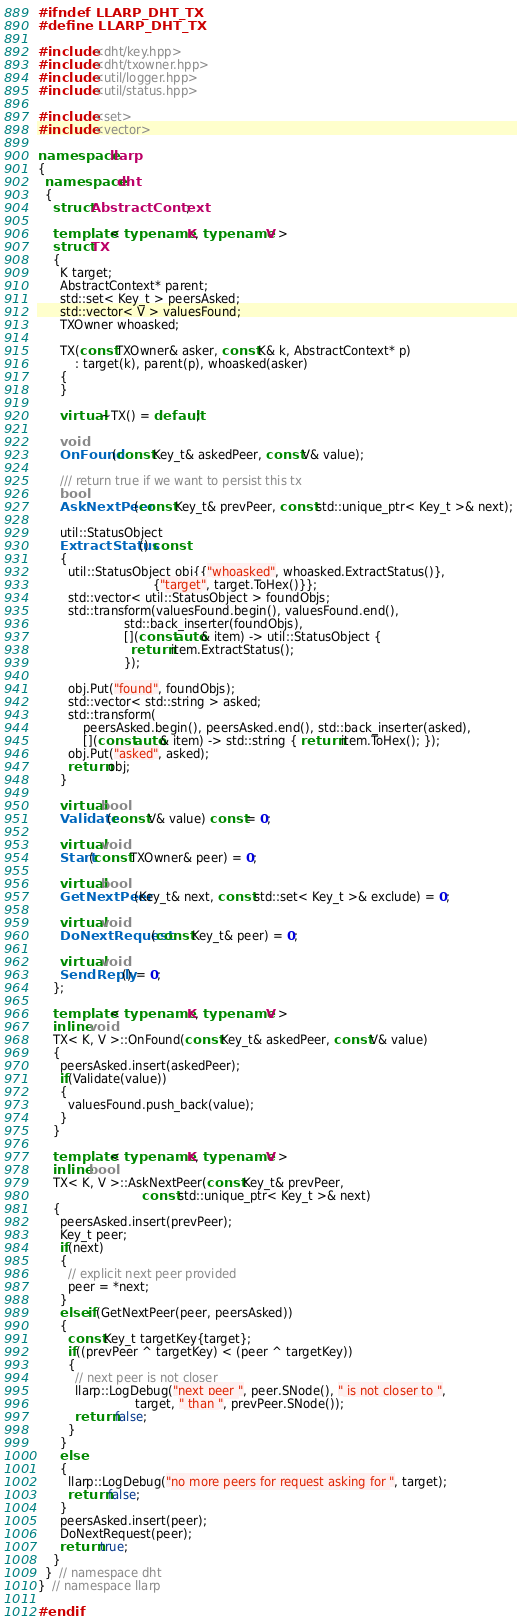Convert code to text. <code><loc_0><loc_0><loc_500><loc_500><_C++_>#ifndef LLARP_DHT_TX
#define LLARP_DHT_TX

#include <dht/key.hpp>
#include <dht/txowner.hpp>
#include <util/logger.hpp>
#include <util/status.hpp>

#include <set>
#include <vector>

namespace llarp
{
  namespace dht
  {
    struct AbstractContext;

    template < typename K, typename V >
    struct TX
    {
      K target;
      AbstractContext* parent;
      std::set< Key_t > peersAsked;
      std::vector< V > valuesFound;
      TXOwner whoasked;

      TX(const TXOwner& asker, const K& k, AbstractContext* p)
          : target(k), parent(p), whoasked(asker)
      {
      }

      virtual ~TX() = default;

      void
      OnFound(const Key_t& askedPeer, const V& value);

      /// return true if we want to persist this tx
      bool
      AskNextPeer(const Key_t& prevPeer, const std::unique_ptr< Key_t >& next);

      util::StatusObject
      ExtractStatus() const
      {
        util::StatusObject obj{{"whoasked", whoasked.ExtractStatus()},
                               {"target", target.ToHex()}};
        std::vector< util::StatusObject > foundObjs;
        std::transform(valuesFound.begin(), valuesFound.end(),
                       std::back_inserter(foundObjs),
                       [](const auto& item) -> util::StatusObject {
                         return item.ExtractStatus();
                       });

        obj.Put("found", foundObjs);
        std::vector< std::string > asked;
        std::transform(
            peersAsked.begin(), peersAsked.end(), std::back_inserter(asked),
            [](const auto& item) -> std::string { return item.ToHex(); });
        obj.Put("asked", asked);
        return obj;
      }

      virtual bool
      Validate(const V& value) const = 0;

      virtual void
      Start(const TXOwner& peer) = 0;

      virtual bool
      GetNextPeer(Key_t& next, const std::set< Key_t >& exclude) = 0;

      virtual void
      DoNextRequest(const Key_t& peer) = 0;

      virtual void
      SendReply() = 0;
    };

    template < typename K, typename V >
    inline void
    TX< K, V >::OnFound(const Key_t& askedPeer, const V& value)
    {
      peersAsked.insert(askedPeer);
      if(Validate(value))
      {
        valuesFound.push_back(value);
      }
    }

    template < typename K, typename V >
    inline bool
    TX< K, V >::AskNextPeer(const Key_t& prevPeer,
                            const std::unique_ptr< Key_t >& next)
    {
      peersAsked.insert(prevPeer);
      Key_t peer;
      if(next)
      {
        // explicit next peer provided
        peer = *next;
      }
      else if(GetNextPeer(peer, peersAsked))
      {
        const Key_t targetKey{target};
        if((prevPeer ^ targetKey) < (peer ^ targetKey))
        {
          // next peer is not closer
          llarp::LogDebug("next peer ", peer.SNode(), " is not closer to ",
                          target, " than ", prevPeer.SNode());
          return false;
        }
      }
      else
      {
        llarp::LogDebug("no more peers for request asking for ", target);
        return false;
      }
      peersAsked.insert(peer);
      DoNextRequest(peer);
      return true;
    }
  }  // namespace dht
}  // namespace llarp

#endif
</code> 